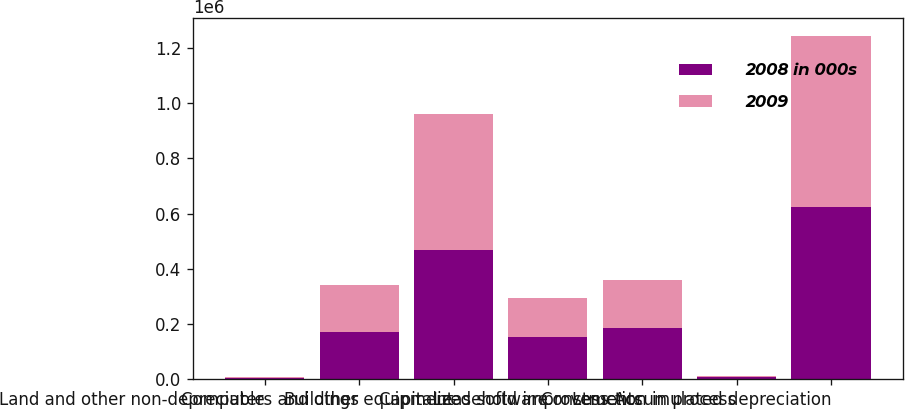<chart> <loc_0><loc_0><loc_500><loc_500><stacked_bar_chart><ecel><fcel>Land and other non-depreciable<fcel>Buildings<fcel>Computers and other equipment<fcel>Capitalized software<fcel>Leasehold improvements<fcel>Construction in process<fcel>Less Accumulated depreciation<nl><fcel>2008 in 000s<fcel>5353<fcel>171785<fcel>469066<fcel>153771<fcel>187180<fcel>6209<fcel>625075<nl><fcel>2009<fcel>1887<fcel>170790<fcel>490365<fcel>142164<fcel>172572<fcel>6346<fcel>620460<nl></chart> 